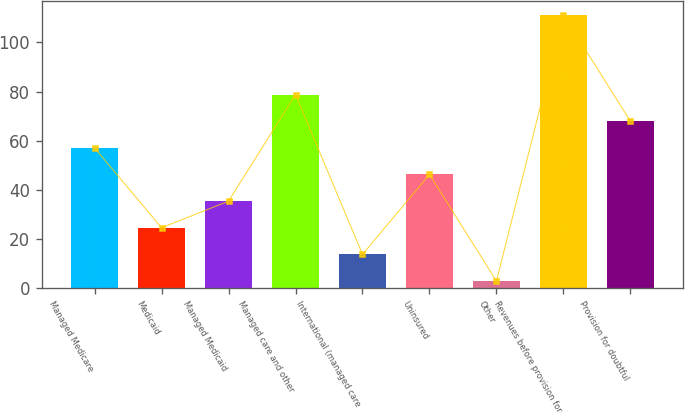<chart> <loc_0><loc_0><loc_500><loc_500><bar_chart><fcel>Managed Medicare<fcel>Medicaid<fcel>Managed Medicaid<fcel>Managed care and other<fcel>International (managed care<fcel>Uninsured<fcel>Other<fcel>Revenues before provision for<fcel>Provision for doubtful<nl><fcel>57.05<fcel>24.5<fcel>35.35<fcel>78.75<fcel>13.65<fcel>46.2<fcel>2.8<fcel>111.3<fcel>67.9<nl></chart> 